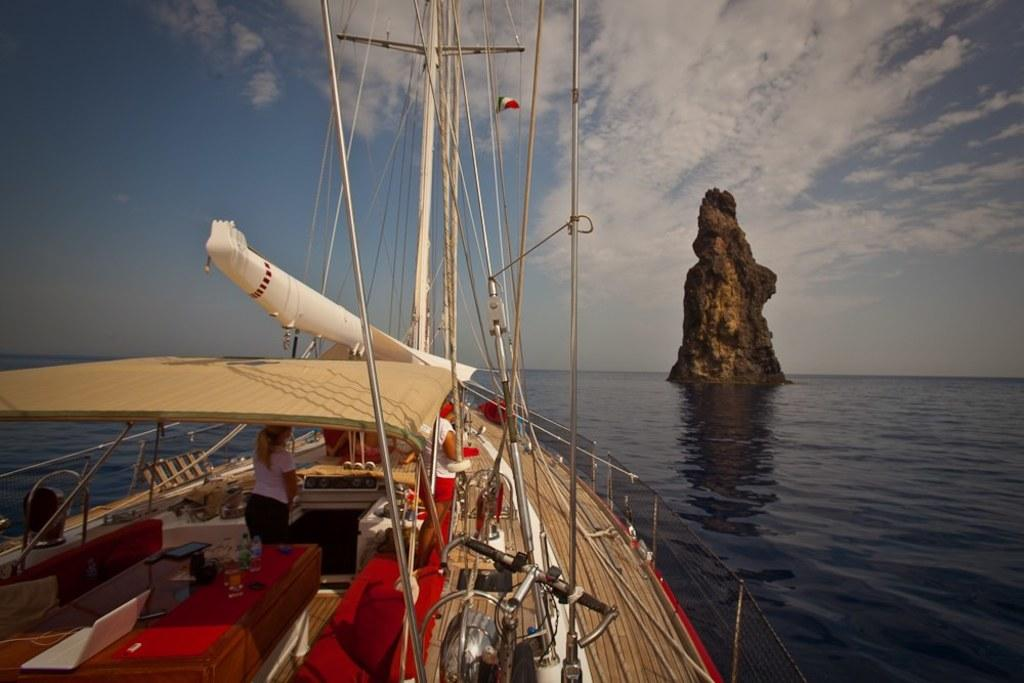What is the main subject of the image? The main subject of the image is a boat. What can be seen on the boat? There are people and other objects on the boat. What is visible in the background of the image? Water and a rock are visible in the background. What is the condition of the sky in the image? The sky is visible at the top of the image, and there are clouds present. What type of house can be seen in the image? There is no house present in the image; it features a boat on water with a rock in the background. 